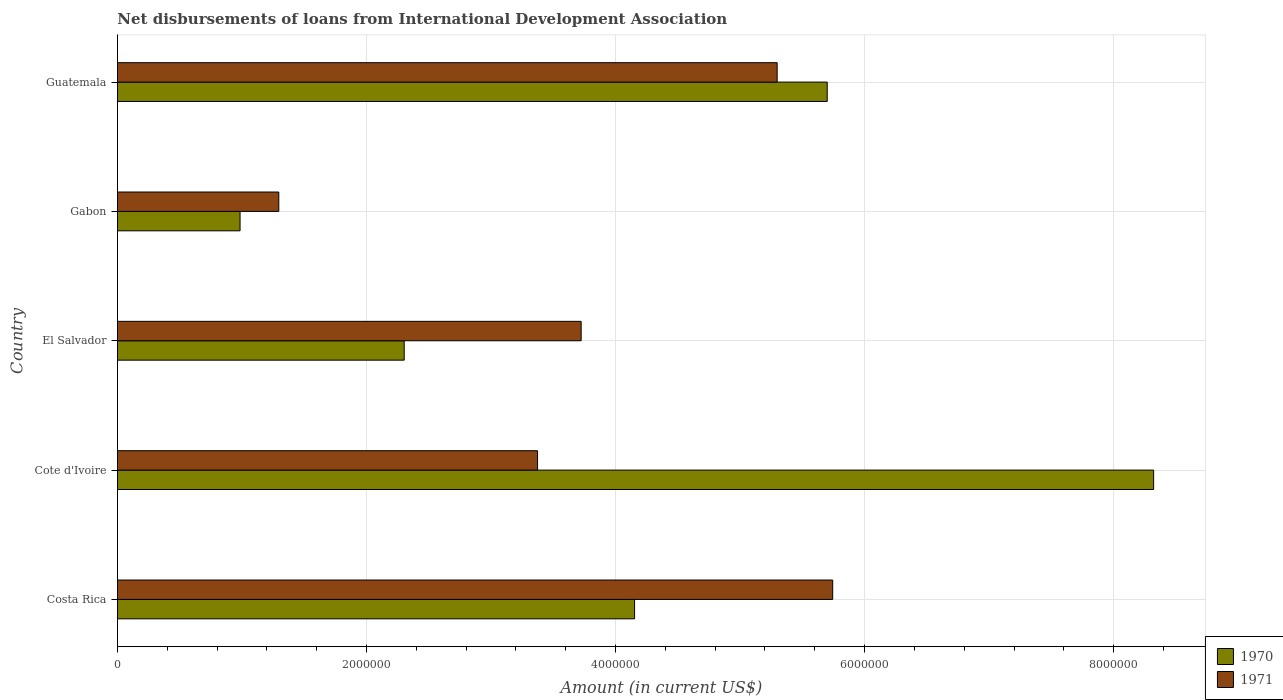How many different coloured bars are there?
Give a very brief answer. 2. Are the number of bars per tick equal to the number of legend labels?
Offer a very short reply. Yes. What is the label of the 4th group of bars from the top?
Keep it short and to the point. Cote d'Ivoire. In how many cases, is the number of bars for a given country not equal to the number of legend labels?
Your answer should be very brief. 0. What is the amount of loans disbursed in 1970 in El Salvador?
Your response must be concise. 2.30e+06. Across all countries, what is the maximum amount of loans disbursed in 1970?
Your response must be concise. 8.32e+06. Across all countries, what is the minimum amount of loans disbursed in 1971?
Offer a terse response. 1.30e+06. In which country was the amount of loans disbursed in 1970 maximum?
Your answer should be very brief. Cote d'Ivoire. In which country was the amount of loans disbursed in 1970 minimum?
Your answer should be very brief. Gabon. What is the total amount of loans disbursed in 1971 in the graph?
Make the answer very short. 1.94e+07. What is the difference between the amount of loans disbursed in 1971 in Cote d'Ivoire and that in El Salvador?
Provide a succinct answer. -3.50e+05. What is the difference between the amount of loans disbursed in 1970 in Gabon and the amount of loans disbursed in 1971 in Guatemala?
Make the answer very short. -4.31e+06. What is the average amount of loans disbursed in 1970 per country?
Make the answer very short. 4.29e+06. What is the difference between the amount of loans disbursed in 1970 and amount of loans disbursed in 1971 in Guatemala?
Keep it short and to the point. 4.02e+05. In how many countries, is the amount of loans disbursed in 1970 greater than 7600000 US$?
Give a very brief answer. 1. What is the ratio of the amount of loans disbursed in 1971 in Costa Rica to that in El Salvador?
Your response must be concise. 1.54. Is the amount of loans disbursed in 1970 in Costa Rica less than that in Cote d'Ivoire?
Your answer should be very brief. Yes. Is the difference between the amount of loans disbursed in 1970 in El Salvador and Gabon greater than the difference between the amount of loans disbursed in 1971 in El Salvador and Gabon?
Ensure brevity in your answer.  No. What is the difference between the highest and the second highest amount of loans disbursed in 1971?
Your response must be concise. 4.46e+05. What is the difference between the highest and the lowest amount of loans disbursed in 1970?
Your answer should be very brief. 7.34e+06. In how many countries, is the amount of loans disbursed in 1970 greater than the average amount of loans disbursed in 1970 taken over all countries?
Provide a succinct answer. 2. What does the 1st bar from the bottom in Guatemala represents?
Your answer should be very brief. 1970. What is the difference between two consecutive major ticks on the X-axis?
Keep it short and to the point. 2.00e+06. Are the values on the major ticks of X-axis written in scientific E-notation?
Provide a short and direct response. No. Does the graph contain grids?
Your answer should be very brief. Yes. How are the legend labels stacked?
Offer a very short reply. Vertical. What is the title of the graph?
Make the answer very short. Net disbursements of loans from International Development Association. Does "1984" appear as one of the legend labels in the graph?
Offer a very short reply. No. What is the label or title of the X-axis?
Offer a very short reply. Amount (in current US$). What is the label or title of the Y-axis?
Your response must be concise. Country. What is the Amount (in current US$) in 1970 in Costa Rica?
Provide a succinct answer. 4.15e+06. What is the Amount (in current US$) in 1971 in Costa Rica?
Keep it short and to the point. 5.74e+06. What is the Amount (in current US$) in 1970 in Cote d'Ivoire?
Give a very brief answer. 8.32e+06. What is the Amount (in current US$) of 1971 in Cote d'Ivoire?
Ensure brevity in your answer.  3.37e+06. What is the Amount (in current US$) of 1970 in El Salvador?
Give a very brief answer. 2.30e+06. What is the Amount (in current US$) in 1971 in El Salvador?
Your response must be concise. 3.72e+06. What is the Amount (in current US$) of 1970 in Gabon?
Keep it short and to the point. 9.85e+05. What is the Amount (in current US$) of 1971 in Gabon?
Provide a succinct answer. 1.30e+06. What is the Amount (in current US$) of 1970 in Guatemala?
Your answer should be very brief. 5.70e+06. What is the Amount (in current US$) of 1971 in Guatemala?
Your answer should be very brief. 5.30e+06. Across all countries, what is the maximum Amount (in current US$) in 1970?
Your response must be concise. 8.32e+06. Across all countries, what is the maximum Amount (in current US$) in 1971?
Your answer should be very brief. 5.74e+06. Across all countries, what is the minimum Amount (in current US$) of 1970?
Offer a very short reply. 9.85e+05. Across all countries, what is the minimum Amount (in current US$) of 1971?
Your response must be concise. 1.30e+06. What is the total Amount (in current US$) in 1970 in the graph?
Your answer should be very brief. 2.15e+07. What is the total Amount (in current US$) in 1971 in the graph?
Offer a very short reply. 1.94e+07. What is the difference between the Amount (in current US$) of 1970 in Costa Rica and that in Cote d'Ivoire?
Ensure brevity in your answer.  -4.17e+06. What is the difference between the Amount (in current US$) of 1971 in Costa Rica and that in Cote d'Ivoire?
Offer a very short reply. 2.37e+06. What is the difference between the Amount (in current US$) of 1970 in Costa Rica and that in El Salvador?
Offer a terse response. 1.85e+06. What is the difference between the Amount (in current US$) in 1971 in Costa Rica and that in El Salvador?
Keep it short and to the point. 2.02e+06. What is the difference between the Amount (in current US$) in 1970 in Costa Rica and that in Gabon?
Provide a succinct answer. 3.17e+06. What is the difference between the Amount (in current US$) of 1971 in Costa Rica and that in Gabon?
Provide a succinct answer. 4.45e+06. What is the difference between the Amount (in current US$) in 1970 in Costa Rica and that in Guatemala?
Keep it short and to the point. -1.55e+06. What is the difference between the Amount (in current US$) of 1971 in Costa Rica and that in Guatemala?
Provide a succinct answer. 4.46e+05. What is the difference between the Amount (in current US$) of 1970 in Cote d'Ivoire and that in El Salvador?
Make the answer very short. 6.02e+06. What is the difference between the Amount (in current US$) of 1971 in Cote d'Ivoire and that in El Salvador?
Ensure brevity in your answer.  -3.50e+05. What is the difference between the Amount (in current US$) in 1970 in Cote d'Ivoire and that in Gabon?
Offer a very short reply. 7.34e+06. What is the difference between the Amount (in current US$) in 1971 in Cote d'Ivoire and that in Gabon?
Your response must be concise. 2.08e+06. What is the difference between the Amount (in current US$) of 1970 in Cote d'Ivoire and that in Guatemala?
Offer a very short reply. 2.62e+06. What is the difference between the Amount (in current US$) of 1971 in Cote d'Ivoire and that in Guatemala?
Your answer should be very brief. -1.92e+06. What is the difference between the Amount (in current US$) of 1970 in El Salvador and that in Gabon?
Your answer should be compact. 1.32e+06. What is the difference between the Amount (in current US$) of 1971 in El Salvador and that in Gabon?
Provide a succinct answer. 2.43e+06. What is the difference between the Amount (in current US$) in 1970 in El Salvador and that in Guatemala?
Provide a succinct answer. -3.40e+06. What is the difference between the Amount (in current US$) of 1971 in El Salvador and that in Guatemala?
Give a very brief answer. -1.57e+06. What is the difference between the Amount (in current US$) in 1970 in Gabon and that in Guatemala?
Provide a short and direct response. -4.72e+06. What is the difference between the Amount (in current US$) of 1971 in Gabon and that in Guatemala?
Offer a terse response. -4.00e+06. What is the difference between the Amount (in current US$) in 1970 in Costa Rica and the Amount (in current US$) in 1971 in Cote d'Ivoire?
Your answer should be very brief. 7.79e+05. What is the difference between the Amount (in current US$) of 1970 in Costa Rica and the Amount (in current US$) of 1971 in El Salvador?
Ensure brevity in your answer.  4.29e+05. What is the difference between the Amount (in current US$) of 1970 in Costa Rica and the Amount (in current US$) of 1971 in Gabon?
Your response must be concise. 2.86e+06. What is the difference between the Amount (in current US$) of 1970 in Costa Rica and the Amount (in current US$) of 1971 in Guatemala?
Your answer should be compact. -1.14e+06. What is the difference between the Amount (in current US$) of 1970 in Cote d'Ivoire and the Amount (in current US$) of 1971 in El Salvador?
Your answer should be very brief. 4.60e+06. What is the difference between the Amount (in current US$) in 1970 in Cote d'Ivoire and the Amount (in current US$) in 1971 in Gabon?
Your response must be concise. 7.02e+06. What is the difference between the Amount (in current US$) in 1970 in Cote d'Ivoire and the Amount (in current US$) in 1971 in Guatemala?
Provide a short and direct response. 3.02e+06. What is the difference between the Amount (in current US$) in 1970 in El Salvador and the Amount (in current US$) in 1971 in Gabon?
Give a very brief answer. 1.01e+06. What is the difference between the Amount (in current US$) of 1970 in El Salvador and the Amount (in current US$) of 1971 in Guatemala?
Your response must be concise. -3.00e+06. What is the difference between the Amount (in current US$) in 1970 in Gabon and the Amount (in current US$) in 1971 in Guatemala?
Make the answer very short. -4.31e+06. What is the average Amount (in current US$) of 1970 per country?
Provide a short and direct response. 4.29e+06. What is the average Amount (in current US$) of 1971 per country?
Offer a terse response. 3.89e+06. What is the difference between the Amount (in current US$) in 1970 and Amount (in current US$) in 1971 in Costa Rica?
Give a very brief answer. -1.59e+06. What is the difference between the Amount (in current US$) in 1970 and Amount (in current US$) in 1971 in Cote d'Ivoire?
Your answer should be compact. 4.95e+06. What is the difference between the Amount (in current US$) of 1970 and Amount (in current US$) of 1971 in El Salvador?
Offer a terse response. -1.42e+06. What is the difference between the Amount (in current US$) in 1970 and Amount (in current US$) in 1971 in Gabon?
Offer a very short reply. -3.11e+05. What is the difference between the Amount (in current US$) of 1970 and Amount (in current US$) of 1971 in Guatemala?
Your answer should be compact. 4.02e+05. What is the ratio of the Amount (in current US$) in 1970 in Costa Rica to that in Cote d'Ivoire?
Offer a terse response. 0.5. What is the ratio of the Amount (in current US$) of 1971 in Costa Rica to that in Cote d'Ivoire?
Give a very brief answer. 1.7. What is the ratio of the Amount (in current US$) of 1970 in Costa Rica to that in El Salvador?
Offer a terse response. 1.8. What is the ratio of the Amount (in current US$) of 1971 in Costa Rica to that in El Salvador?
Your answer should be compact. 1.54. What is the ratio of the Amount (in current US$) of 1970 in Costa Rica to that in Gabon?
Offer a very short reply. 4.22. What is the ratio of the Amount (in current US$) of 1971 in Costa Rica to that in Gabon?
Make the answer very short. 4.43. What is the ratio of the Amount (in current US$) in 1970 in Costa Rica to that in Guatemala?
Offer a very short reply. 0.73. What is the ratio of the Amount (in current US$) in 1971 in Costa Rica to that in Guatemala?
Offer a very short reply. 1.08. What is the ratio of the Amount (in current US$) in 1970 in Cote d'Ivoire to that in El Salvador?
Provide a short and direct response. 3.61. What is the ratio of the Amount (in current US$) of 1971 in Cote d'Ivoire to that in El Salvador?
Offer a terse response. 0.91. What is the ratio of the Amount (in current US$) in 1970 in Cote d'Ivoire to that in Gabon?
Provide a short and direct response. 8.45. What is the ratio of the Amount (in current US$) in 1971 in Cote d'Ivoire to that in Gabon?
Keep it short and to the point. 2.6. What is the ratio of the Amount (in current US$) of 1970 in Cote d'Ivoire to that in Guatemala?
Provide a short and direct response. 1.46. What is the ratio of the Amount (in current US$) in 1971 in Cote d'Ivoire to that in Guatemala?
Keep it short and to the point. 0.64. What is the ratio of the Amount (in current US$) in 1970 in El Salvador to that in Gabon?
Your answer should be very brief. 2.34. What is the ratio of the Amount (in current US$) of 1971 in El Salvador to that in Gabon?
Provide a short and direct response. 2.87. What is the ratio of the Amount (in current US$) in 1970 in El Salvador to that in Guatemala?
Your response must be concise. 0.4. What is the ratio of the Amount (in current US$) in 1971 in El Salvador to that in Guatemala?
Offer a very short reply. 0.7. What is the ratio of the Amount (in current US$) in 1970 in Gabon to that in Guatemala?
Your response must be concise. 0.17. What is the ratio of the Amount (in current US$) in 1971 in Gabon to that in Guatemala?
Provide a succinct answer. 0.24. What is the difference between the highest and the second highest Amount (in current US$) of 1970?
Your answer should be very brief. 2.62e+06. What is the difference between the highest and the second highest Amount (in current US$) of 1971?
Your answer should be compact. 4.46e+05. What is the difference between the highest and the lowest Amount (in current US$) in 1970?
Offer a terse response. 7.34e+06. What is the difference between the highest and the lowest Amount (in current US$) in 1971?
Your answer should be very brief. 4.45e+06. 